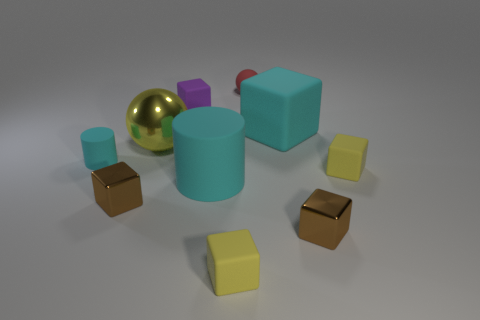Subtract all yellow matte cubes. How many cubes are left? 4 Subtract 3 blocks. How many blocks are left? 3 Subtract all purple blocks. How many blocks are left? 5 Subtract all brown cubes. Subtract all yellow spheres. How many cubes are left? 4 Subtract all blocks. How many objects are left? 4 Subtract 0 purple cylinders. How many objects are left? 10 Subtract all large cyan objects. Subtract all big rubber blocks. How many objects are left? 7 Add 2 cubes. How many cubes are left? 8 Add 4 big metal spheres. How many big metal spheres exist? 5 